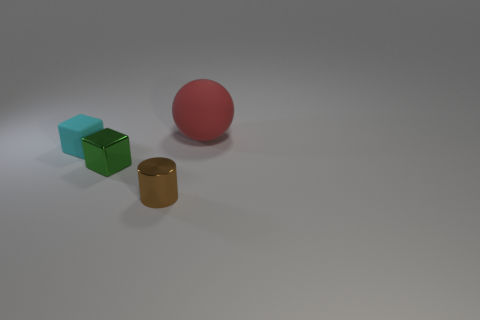Add 4 big yellow balls. How many objects exist? 8 Subtract all balls. How many objects are left? 3 Subtract 0 cyan cylinders. How many objects are left? 4 Subtract all green rubber things. Subtract all tiny cyan blocks. How many objects are left? 3 Add 4 large rubber objects. How many large rubber objects are left? 5 Add 2 tiny red cylinders. How many tiny red cylinders exist? 2 